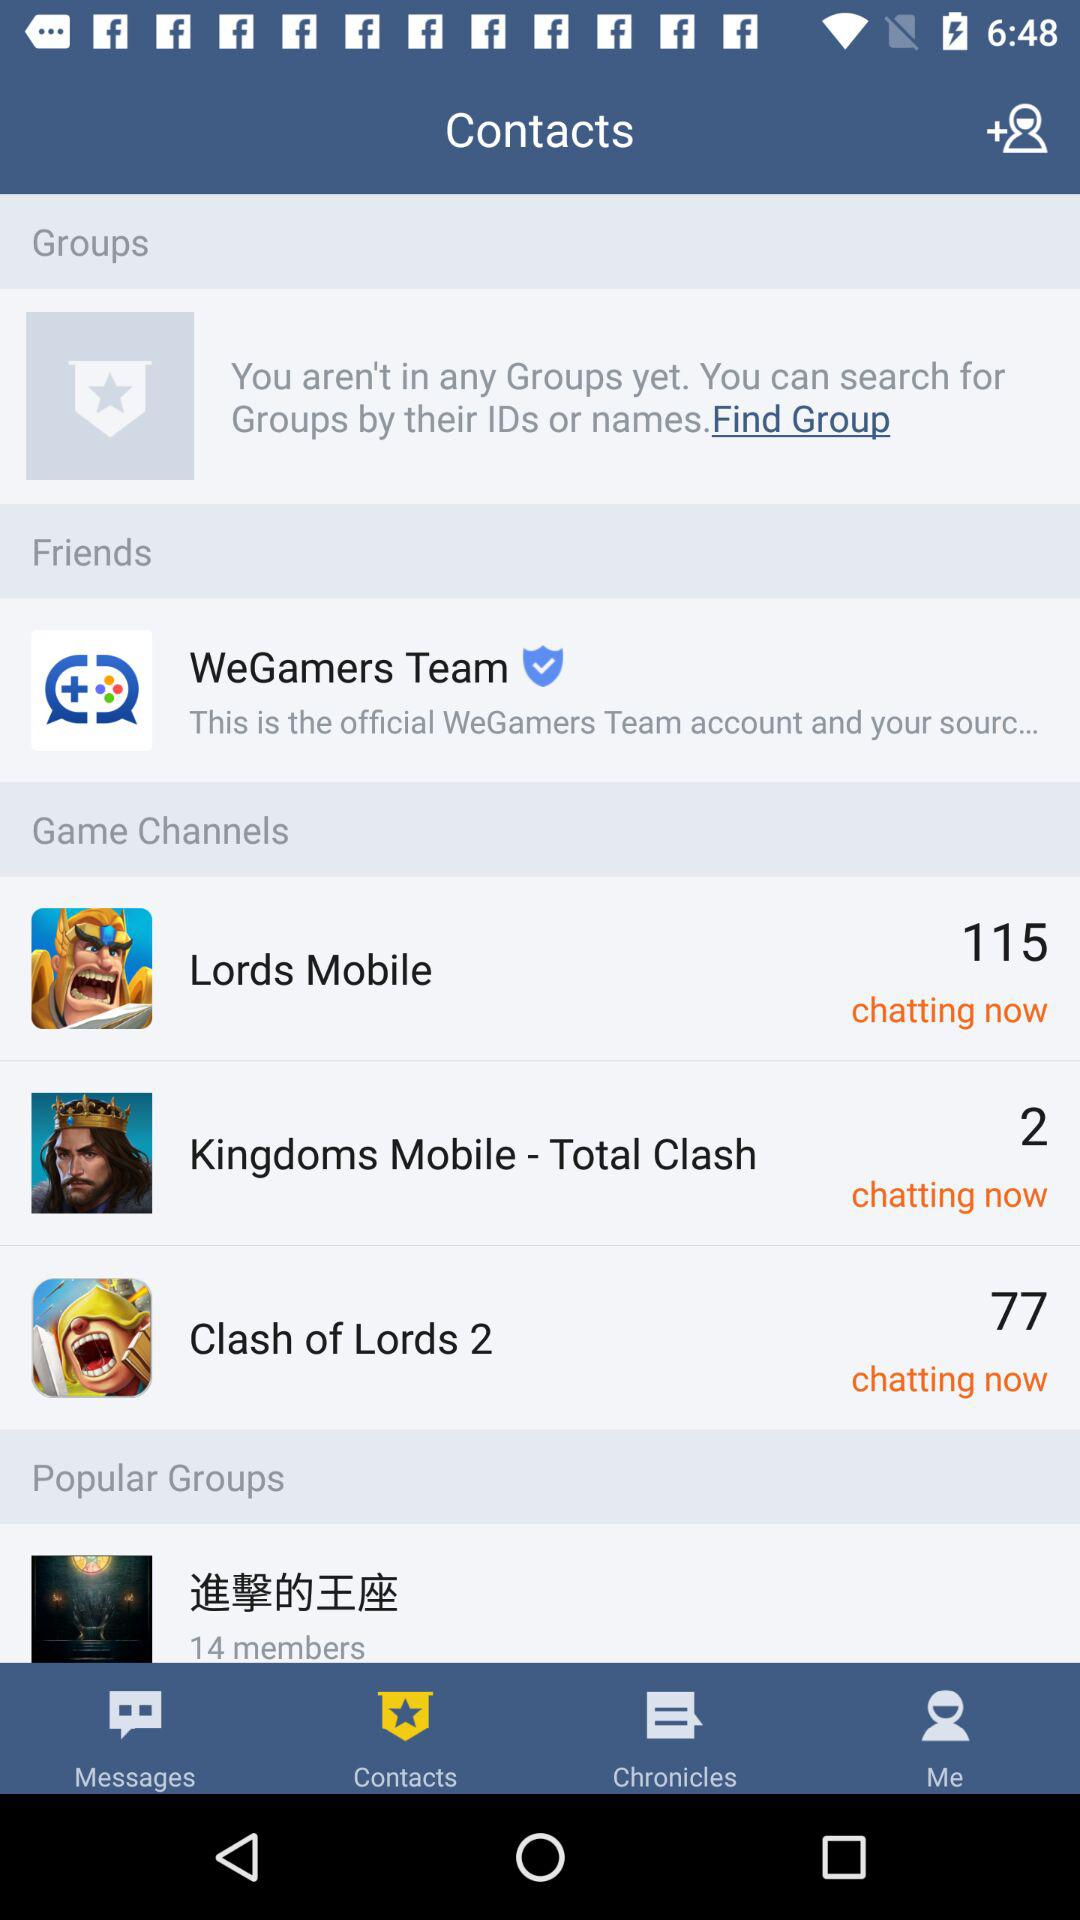What are the game channel options? The game channel options are "Lords Mobile", "Kingdoms Mobile-Total Clash", and "Clash of Lords 2". 